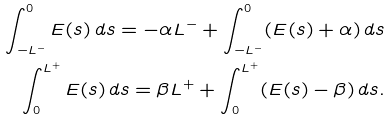Convert formula to latex. <formula><loc_0><loc_0><loc_500><loc_500>\int _ { - L ^ { - } } ^ { 0 } E ( s ) \, d s = - \alpha L ^ { - } + \int _ { - L ^ { - } } ^ { 0 } ( E ( s ) + \alpha ) \, d s \\ \int _ { 0 } ^ { L ^ { + } } E ( s ) \, d s = \beta L ^ { + } + \int _ { 0 } ^ { L ^ { + } } ( E ( s ) - \beta ) \, d s . \\</formula> 